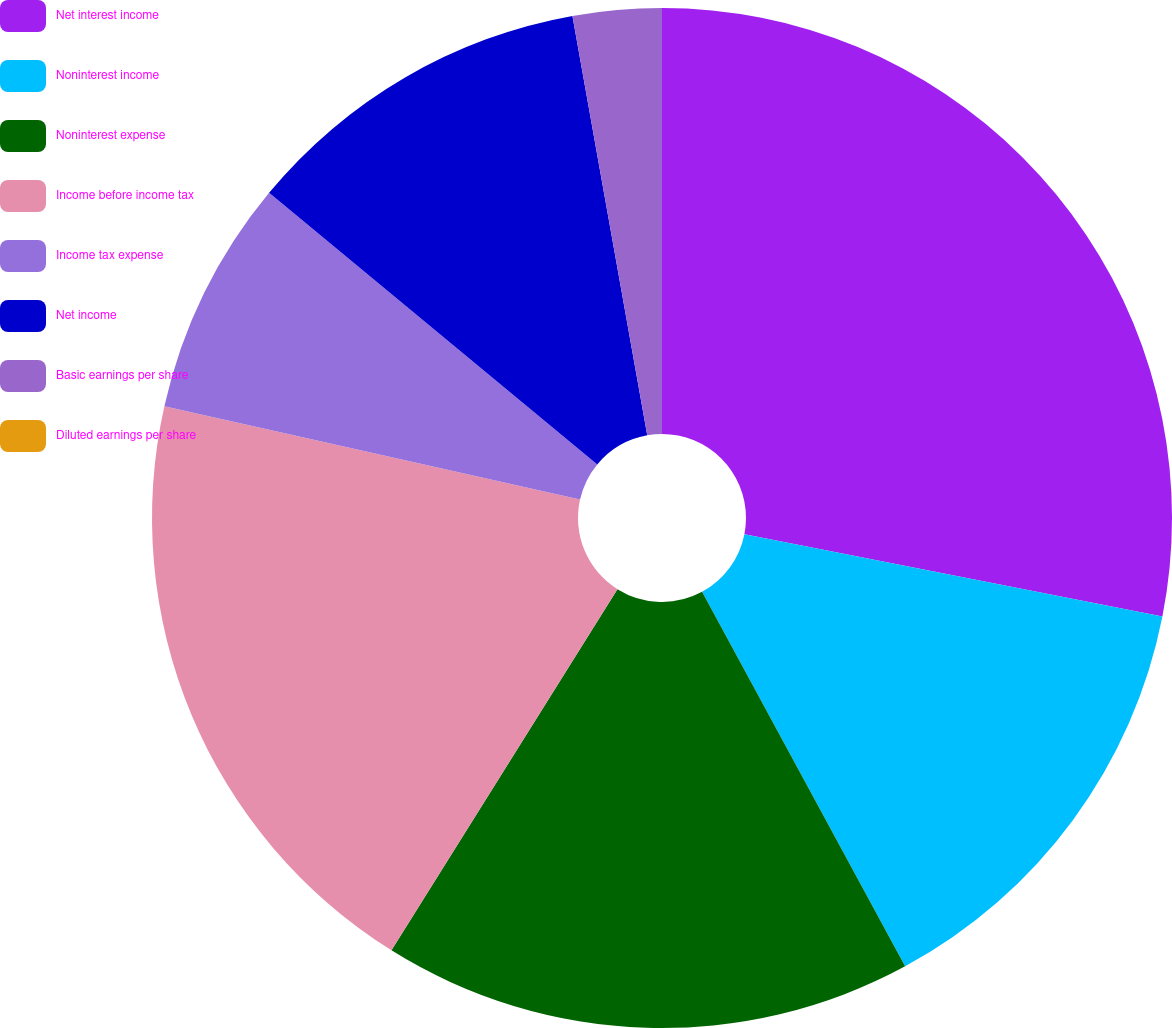<chart> <loc_0><loc_0><loc_500><loc_500><pie_chart><fcel>Net interest income<fcel>Noninterest income<fcel>Noninterest expense<fcel>Income before income tax<fcel>Income tax expense<fcel>Net income<fcel>Basic earnings per share<fcel>Diluted earnings per share<nl><fcel>28.1%<fcel>14.0%<fcel>16.81%<fcel>19.62%<fcel>7.49%<fcel>11.19%<fcel>2.81%<fcel>0.0%<nl></chart> 